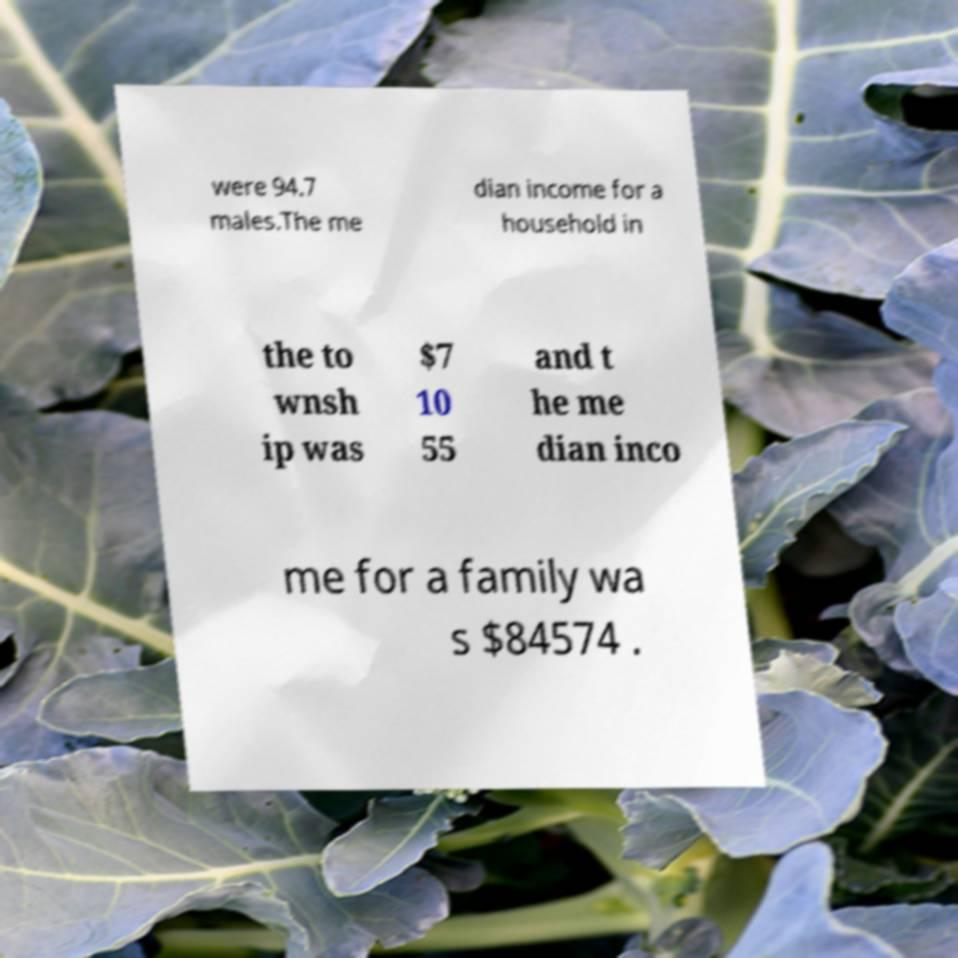I need the written content from this picture converted into text. Can you do that? were 94.7 males.The me dian income for a household in the to wnsh ip was $7 10 55 and t he me dian inco me for a family wa s $84574 . 